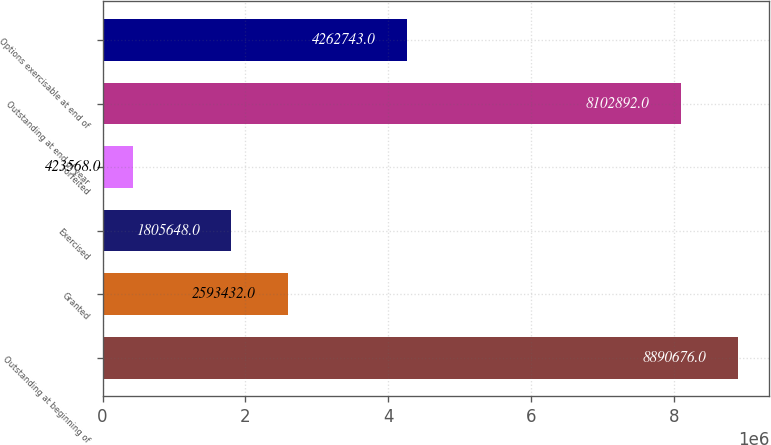Convert chart to OTSL. <chart><loc_0><loc_0><loc_500><loc_500><bar_chart><fcel>Outstanding at beginning of<fcel>Granted<fcel>Exercised<fcel>Forfeited<fcel>Outstanding at end of year<fcel>Options exercisable at end of<nl><fcel>8.89068e+06<fcel>2.59343e+06<fcel>1.80565e+06<fcel>423568<fcel>8.10289e+06<fcel>4.26274e+06<nl></chart> 